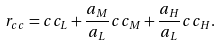Convert formula to latex. <formula><loc_0><loc_0><loc_500><loc_500>r _ { c c } = c c _ { L } + \frac { a _ { M } } { a _ { L } } c c _ { M } + \frac { a _ { H } } { a _ { L } } c c _ { H } .</formula> 